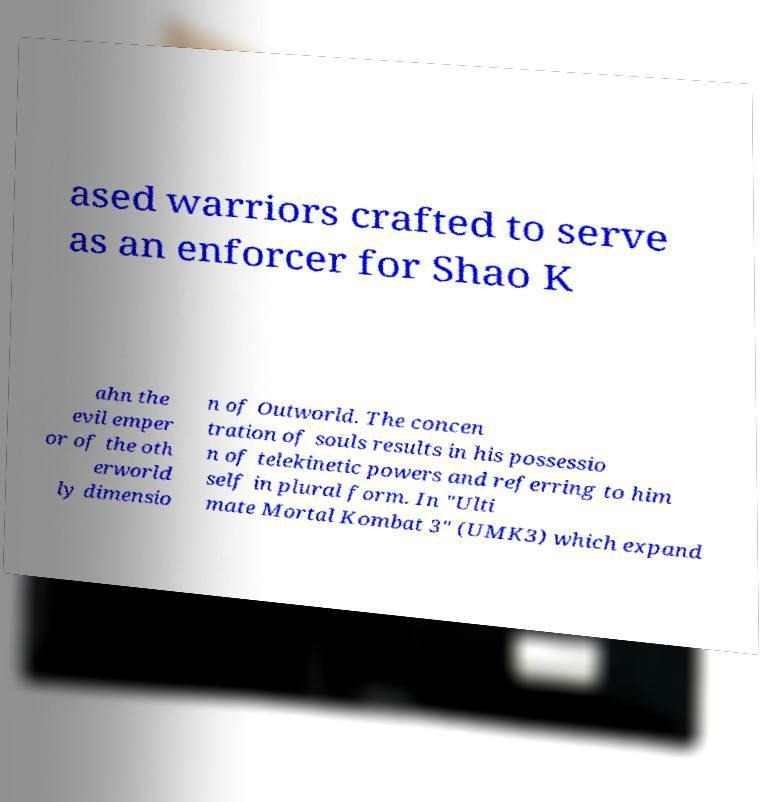There's text embedded in this image that I need extracted. Can you transcribe it verbatim? ased warriors crafted to serve as an enforcer for Shao K ahn the evil emper or of the oth erworld ly dimensio n of Outworld. The concen tration of souls results in his possessio n of telekinetic powers and referring to him self in plural form. In "Ulti mate Mortal Kombat 3" (UMK3) which expand 